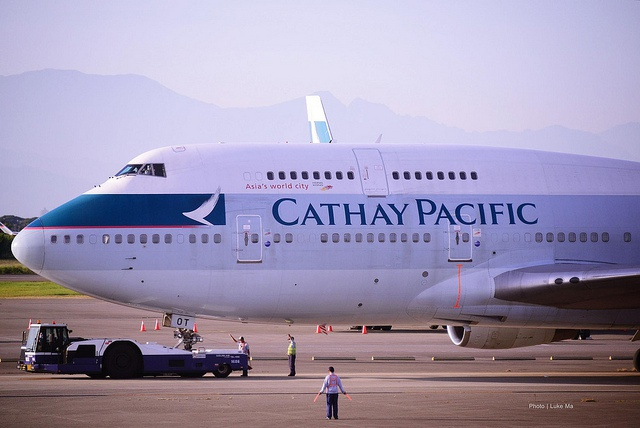Describe the objects in this image and their specific colors. I can see airplane in lavender, violet, and gray tones, truck in lavender, black, darkgray, and gray tones, truck in lavender, black, gray, and darkgray tones, people in lavender, black, purple, darkgray, and violet tones, and people in lavender, black, navy, purple, and darkgray tones in this image. 